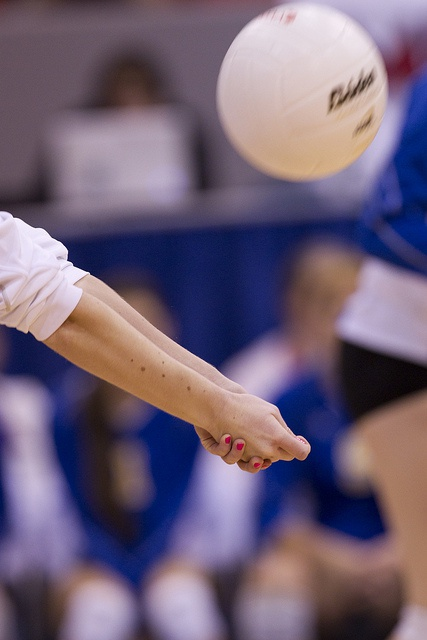Describe the objects in this image and their specific colors. I can see people in maroon, navy, gray, and black tones, people in maroon, navy, black, purple, and darkgray tones, people in maroon, salmon, pink, lavender, and tan tones, sports ball in maroon, tan, lightgray, and darkgray tones, and people in maroon, darkgray, purple, violet, and gray tones in this image. 